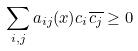<formula> <loc_0><loc_0><loc_500><loc_500>\sum _ { i , j } a _ { i j } ( x ) c _ { i } \overline { c _ { j } } \geq 0</formula> 